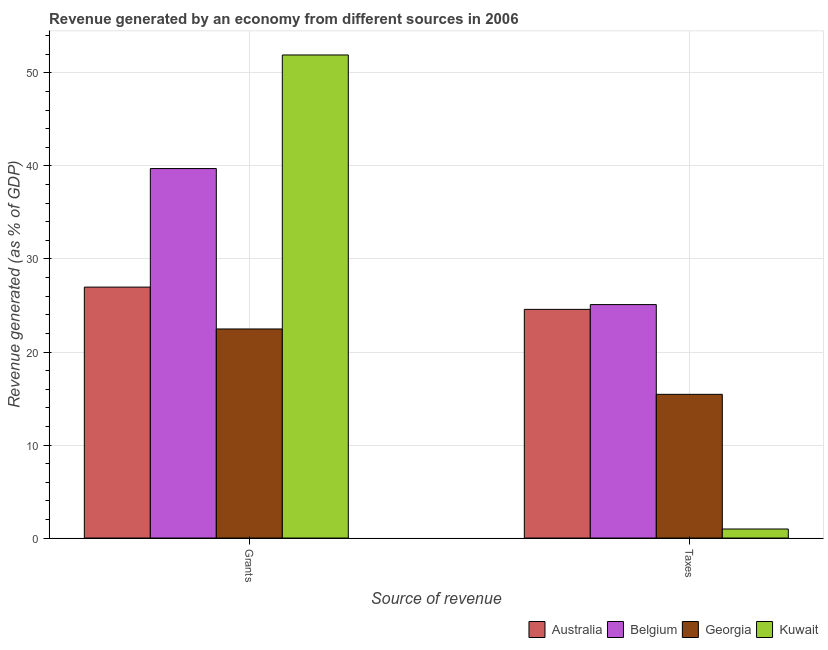How many groups of bars are there?
Your answer should be very brief. 2. Are the number of bars per tick equal to the number of legend labels?
Offer a very short reply. Yes. How many bars are there on the 1st tick from the left?
Your answer should be compact. 4. What is the label of the 1st group of bars from the left?
Provide a succinct answer. Grants. What is the revenue generated by taxes in Belgium?
Make the answer very short. 25.1. Across all countries, what is the maximum revenue generated by taxes?
Your answer should be compact. 25.1. Across all countries, what is the minimum revenue generated by grants?
Offer a very short reply. 22.48. In which country was the revenue generated by grants maximum?
Provide a succinct answer. Kuwait. In which country was the revenue generated by taxes minimum?
Your response must be concise. Kuwait. What is the total revenue generated by grants in the graph?
Provide a short and direct response. 141.1. What is the difference between the revenue generated by taxes in Georgia and that in Kuwait?
Give a very brief answer. 14.48. What is the difference between the revenue generated by taxes in Georgia and the revenue generated by grants in Belgium?
Provide a short and direct response. -24.27. What is the average revenue generated by grants per country?
Your answer should be compact. 35.28. What is the difference between the revenue generated by taxes and revenue generated by grants in Australia?
Keep it short and to the point. -2.4. In how many countries, is the revenue generated by grants greater than 52 %?
Your answer should be very brief. 0. What is the ratio of the revenue generated by taxes in Australia to that in Belgium?
Keep it short and to the point. 0.98. Is the revenue generated by grants in Australia less than that in Kuwait?
Keep it short and to the point. Yes. In how many countries, is the revenue generated by grants greater than the average revenue generated by grants taken over all countries?
Keep it short and to the point. 2. What does the 3rd bar from the left in Grants represents?
Keep it short and to the point. Georgia. What does the 2nd bar from the right in Grants represents?
Provide a succinct answer. Georgia. How many bars are there?
Give a very brief answer. 8. What is the difference between two consecutive major ticks on the Y-axis?
Offer a very short reply. 10. Where does the legend appear in the graph?
Ensure brevity in your answer.  Bottom right. How many legend labels are there?
Keep it short and to the point. 4. What is the title of the graph?
Keep it short and to the point. Revenue generated by an economy from different sources in 2006. What is the label or title of the X-axis?
Make the answer very short. Source of revenue. What is the label or title of the Y-axis?
Make the answer very short. Revenue generated (as % of GDP). What is the Revenue generated (as % of GDP) in Australia in Grants?
Provide a short and direct response. 26.98. What is the Revenue generated (as % of GDP) in Belgium in Grants?
Provide a short and direct response. 39.72. What is the Revenue generated (as % of GDP) of Georgia in Grants?
Your response must be concise. 22.48. What is the Revenue generated (as % of GDP) of Kuwait in Grants?
Provide a succinct answer. 51.93. What is the Revenue generated (as % of GDP) in Australia in Taxes?
Provide a succinct answer. 24.58. What is the Revenue generated (as % of GDP) in Belgium in Taxes?
Make the answer very short. 25.1. What is the Revenue generated (as % of GDP) in Georgia in Taxes?
Your answer should be very brief. 15.45. What is the Revenue generated (as % of GDP) in Kuwait in Taxes?
Make the answer very short. 0.97. Across all Source of revenue, what is the maximum Revenue generated (as % of GDP) of Australia?
Offer a terse response. 26.98. Across all Source of revenue, what is the maximum Revenue generated (as % of GDP) in Belgium?
Make the answer very short. 39.72. Across all Source of revenue, what is the maximum Revenue generated (as % of GDP) in Georgia?
Provide a succinct answer. 22.48. Across all Source of revenue, what is the maximum Revenue generated (as % of GDP) of Kuwait?
Provide a short and direct response. 51.93. Across all Source of revenue, what is the minimum Revenue generated (as % of GDP) of Australia?
Make the answer very short. 24.58. Across all Source of revenue, what is the minimum Revenue generated (as % of GDP) of Belgium?
Give a very brief answer. 25.1. Across all Source of revenue, what is the minimum Revenue generated (as % of GDP) in Georgia?
Your answer should be compact. 15.45. Across all Source of revenue, what is the minimum Revenue generated (as % of GDP) in Kuwait?
Your answer should be compact. 0.97. What is the total Revenue generated (as % of GDP) of Australia in the graph?
Your answer should be compact. 51.56. What is the total Revenue generated (as % of GDP) in Belgium in the graph?
Ensure brevity in your answer.  64.82. What is the total Revenue generated (as % of GDP) of Georgia in the graph?
Give a very brief answer. 37.92. What is the total Revenue generated (as % of GDP) of Kuwait in the graph?
Make the answer very short. 52.9. What is the difference between the Revenue generated (as % of GDP) in Australia in Grants and that in Taxes?
Ensure brevity in your answer.  2.4. What is the difference between the Revenue generated (as % of GDP) in Belgium in Grants and that in Taxes?
Provide a short and direct response. 14.62. What is the difference between the Revenue generated (as % of GDP) in Georgia in Grants and that in Taxes?
Provide a succinct answer. 7.03. What is the difference between the Revenue generated (as % of GDP) of Kuwait in Grants and that in Taxes?
Make the answer very short. 50.96. What is the difference between the Revenue generated (as % of GDP) in Australia in Grants and the Revenue generated (as % of GDP) in Belgium in Taxes?
Provide a succinct answer. 1.88. What is the difference between the Revenue generated (as % of GDP) of Australia in Grants and the Revenue generated (as % of GDP) of Georgia in Taxes?
Offer a very short reply. 11.53. What is the difference between the Revenue generated (as % of GDP) in Australia in Grants and the Revenue generated (as % of GDP) in Kuwait in Taxes?
Your answer should be very brief. 26.01. What is the difference between the Revenue generated (as % of GDP) of Belgium in Grants and the Revenue generated (as % of GDP) of Georgia in Taxes?
Give a very brief answer. 24.27. What is the difference between the Revenue generated (as % of GDP) in Belgium in Grants and the Revenue generated (as % of GDP) in Kuwait in Taxes?
Keep it short and to the point. 38.75. What is the difference between the Revenue generated (as % of GDP) of Georgia in Grants and the Revenue generated (as % of GDP) of Kuwait in Taxes?
Ensure brevity in your answer.  21.5. What is the average Revenue generated (as % of GDP) in Australia per Source of revenue?
Your answer should be compact. 25.78. What is the average Revenue generated (as % of GDP) in Belgium per Source of revenue?
Provide a short and direct response. 32.41. What is the average Revenue generated (as % of GDP) of Georgia per Source of revenue?
Your answer should be very brief. 18.96. What is the average Revenue generated (as % of GDP) in Kuwait per Source of revenue?
Keep it short and to the point. 26.45. What is the difference between the Revenue generated (as % of GDP) in Australia and Revenue generated (as % of GDP) in Belgium in Grants?
Your answer should be compact. -12.74. What is the difference between the Revenue generated (as % of GDP) of Australia and Revenue generated (as % of GDP) of Georgia in Grants?
Offer a terse response. 4.5. What is the difference between the Revenue generated (as % of GDP) in Australia and Revenue generated (as % of GDP) in Kuwait in Grants?
Your response must be concise. -24.95. What is the difference between the Revenue generated (as % of GDP) of Belgium and Revenue generated (as % of GDP) of Georgia in Grants?
Your answer should be very brief. 17.25. What is the difference between the Revenue generated (as % of GDP) in Belgium and Revenue generated (as % of GDP) in Kuwait in Grants?
Offer a very short reply. -12.21. What is the difference between the Revenue generated (as % of GDP) of Georgia and Revenue generated (as % of GDP) of Kuwait in Grants?
Your response must be concise. -29.46. What is the difference between the Revenue generated (as % of GDP) of Australia and Revenue generated (as % of GDP) of Belgium in Taxes?
Your response must be concise. -0.51. What is the difference between the Revenue generated (as % of GDP) of Australia and Revenue generated (as % of GDP) of Georgia in Taxes?
Offer a very short reply. 9.13. What is the difference between the Revenue generated (as % of GDP) in Australia and Revenue generated (as % of GDP) in Kuwait in Taxes?
Give a very brief answer. 23.61. What is the difference between the Revenue generated (as % of GDP) of Belgium and Revenue generated (as % of GDP) of Georgia in Taxes?
Offer a very short reply. 9.65. What is the difference between the Revenue generated (as % of GDP) of Belgium and Revenue generated (as % of GDP) of Kuwait in Taxes?
Offer a terse response. 24.13. What is the difference between the Revenue generated (as % of GDP) in Georgia and Revenue generated (as % of GDP) in Kuwait in Taxes?
Your answer should be very brief. 14.48. What is the ratio of the Revenue generated (as % of GDP) of Australia in Grants to that in Taxes?
Make the answer very short. 1.1. What is the ratio of the Revenue generated (as % of GDP) in Belgium in Grants to that in Taxes?
Make the answer very short. 1.58. What is the ratio of the Revenue generated (as % of GDP) of Georgia in Grants to that in Taxes?
Provide a short and direct response. 1.45. What is the ratio of the Revenue generated (as % of GDP) of Kuwait in Grants to that in Taxes?
Offer a very short reply. 53.51. What is the difference between the highest and the second highest Revenue generated (as % of GDP) of Australia?
Your answer should be very brief. 2.4. What is the difference between the highest and the second highest Revenue generated (as % of GDP) in Belgium?
Give a very brief answer. 14.62. What is the difference between the highest and the second highest Revenue generated (as % of GDP) of Georgia?
Ensure brevity in your answer.  7.03. What is the difference between the highest and the second highest Revenue generated (as % of GDP) in Kuwait?
Provide a short and direct response. 50.96. What is the difference between the highest and the lowest Revenue generated (as % of GDP) of Australia?
Your answer should be compact. 2.4. What is the difference between the highest and the lowest Revenue generated (as % of GDP) of Belgium?
Provide a short and direct response. 14.62. What is the difference between the highest and the lowest Revenue generated (as % of GDP) in Georgia?
Ensure brevity in your answer.  7.03. What is the difference between the highest and the lowest Revenue generated (as % of GDP) in Kuwait?
Ensure brevity in your answer.  50.96. 